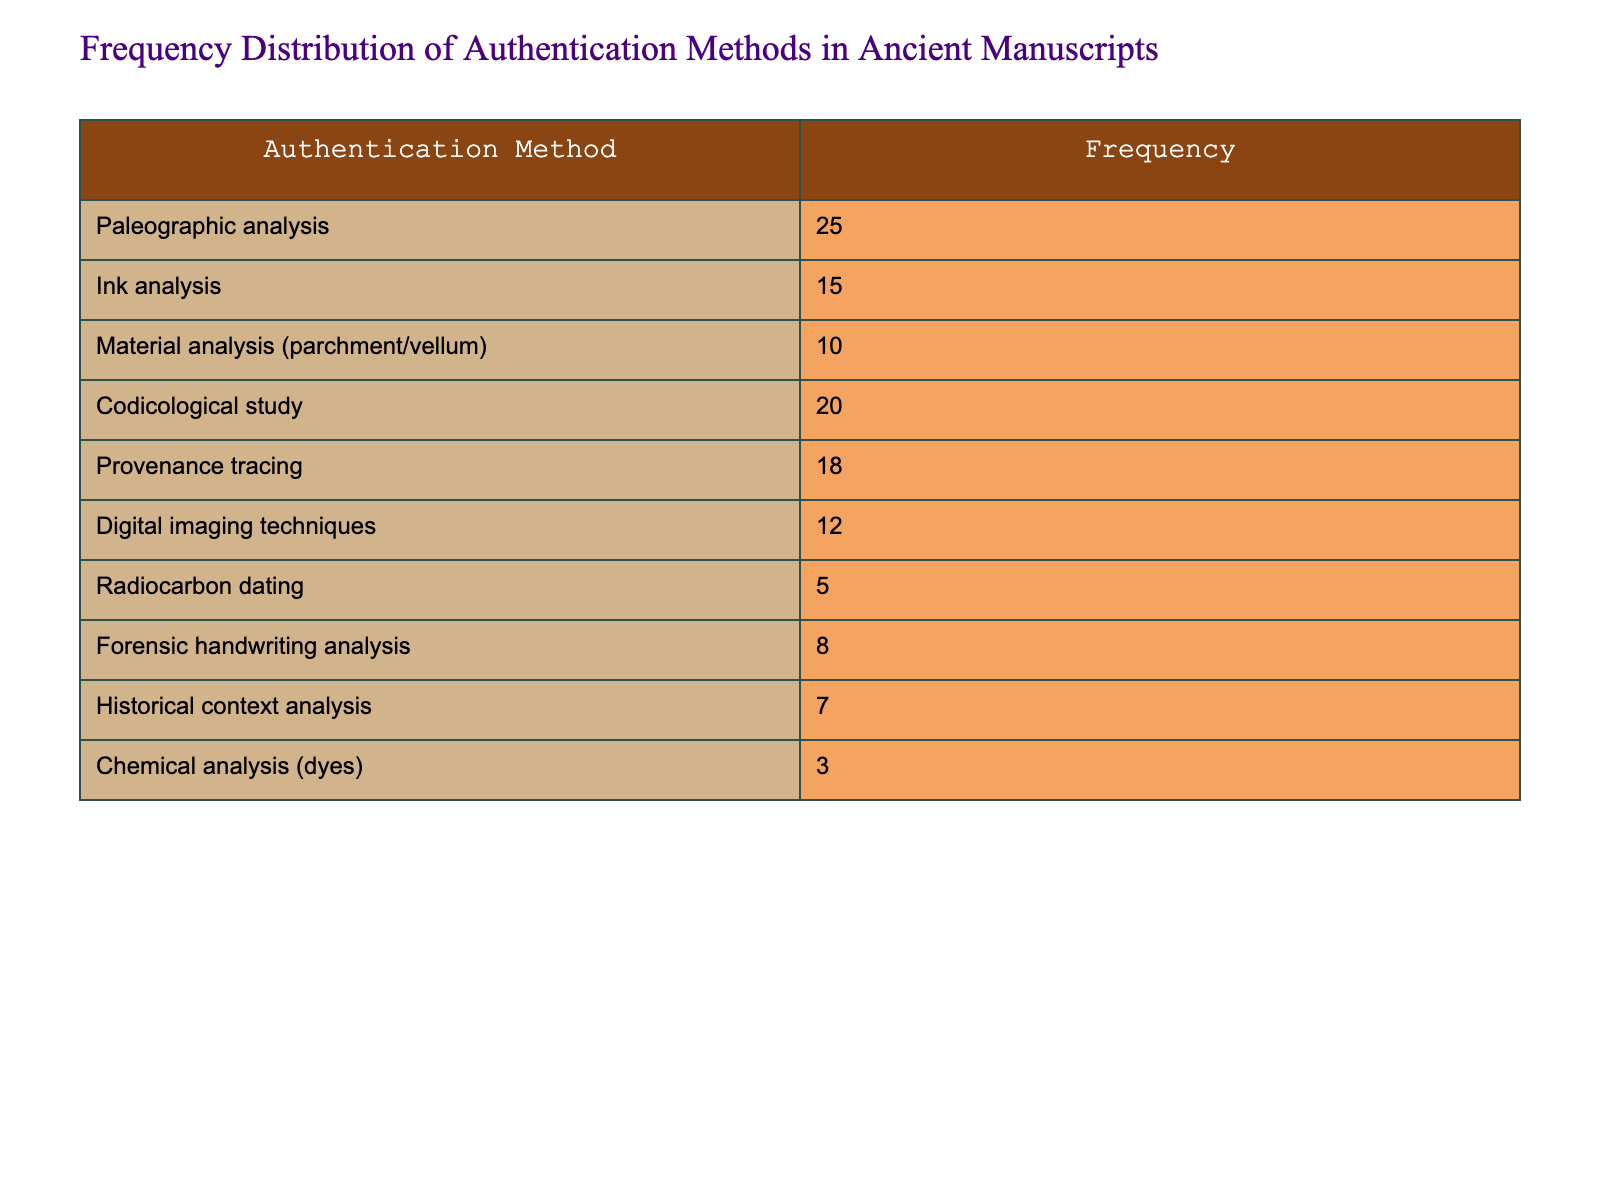What authentication method has the highest frequency? By looking at the frequency column, we see that "Paleographic analysis" has the highest frequency value of 25.
Answer: Paleographic analysis What is the frequency of chemical analysis (dyes)? The table directly shows that "Chemical analysis (dyes)" has a frequency of 3.
Answer: 3 Which two authentication methods have frequencies that add up to at least 35? By scanning the frequency values, "Paleographic analysis" (25) and "Codicological study" (20) can be combined to form 45, which is greater than 35.
Answer: Paleographic analysis and Codicological study Is the frequency of digital imaging techniques greater than that of radiocarbon dating? The frequency for "Digital imaging techniques" is 12, while for "Radiocarbon dating," it is 5. Since 12 is greater than 5, the statement is true.
Answer: Yes What is the total frequency of all authentication methods listed in the table? To find the total frequency, we sum all the values: 25 + 15 + 10 + 20 + 18 + 12 + 5 + 8 + 7 + 3 = 123.
Answer: 123 Which authentication method has the lowest frequency? Looking at the frequencies, "Chemical analysis (dyes)" has the lowest frequency value of 3.
Answer: Chemical analysis (dyes) Are there more methods that are analyzed using material analysis than those using forensic handwriting analysis? "Material analysis (parchment/vellum)" has a frequency of 10, while "Forensic handwriting analysis" has a frequency of 8. Since 10 is greater than 8, the statement is true.
Answer: Yes What is the average frequency across all the authentication methods? The total frequency is 123, and there are 10 methods, so the average is calculated as 123 / 10 = 12.3.
Answer: 12.3 What is the frequency difference between provenance tracing and ink analysis? The frequency for "Provenance tracing" is 18 and for "Ink analysis" is 15. The difference is calculated by subtracting these two values: 18 - 15 = 3.
Answer: 3 